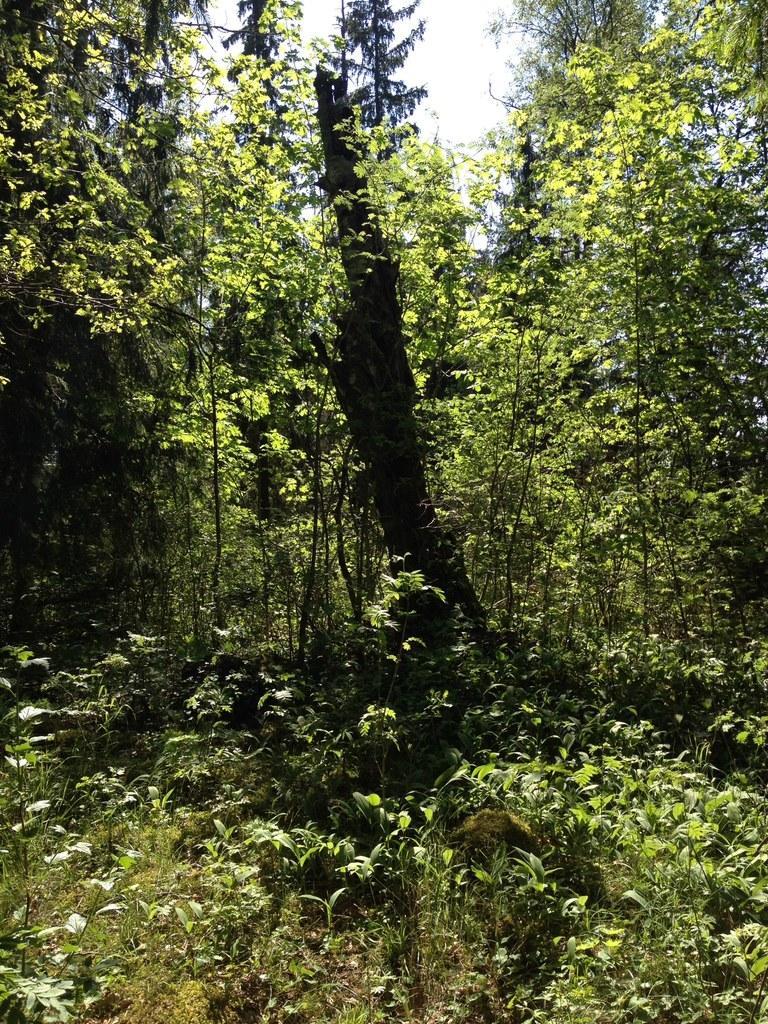Describe this image in one or two sentences. There are plants and there's grass on the ground. In the background, there are trees and clouds in the blue sky. 